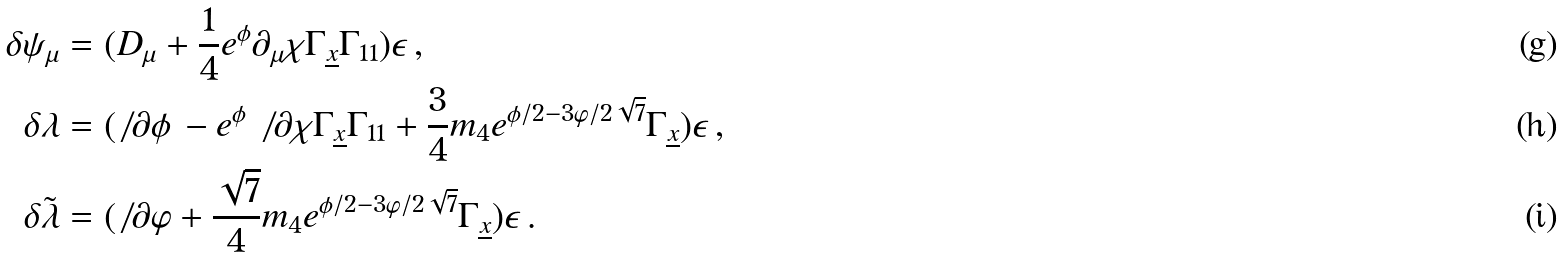Convert formula to latex. <formula><loc_0><loc_0><loc_500><loc_500>\delta \psi _ { \mu } & = ( D _ { \mu } + \frac { 1 } { 4 } e ^ { \phi } \partial _ { \mu } \chi \Gamma _ { \underline { x } } \Gamma _ { 1 1 } ) \epsilon \, , \\ \delta \lambda & = ( \not \, \partial \phi \, - e ^ { \phi } \not \, \partial \chi \Gamma _ { \underline { x } } \Gamma _ { 1 1 } + \frac { 3 } { 4 } m _ { 4 } e ^ { \phi / 2 - 3 \varphi / 2 \sqrt { 7 } } \Gamma _ { \underline { x } } ) \epsilon \, , \\ \ \delta \tilde { \lambda } & = ( \not \, \partial \varphi + \frac { \sqrt { 7 } } { 4 } m _ { 4 } e ^ { \phi / 2 - 3 \varphi / 2 \sqrt { 7 } } \Gamma _ { \underline { x } } ) \epsilon \, .</formula> 